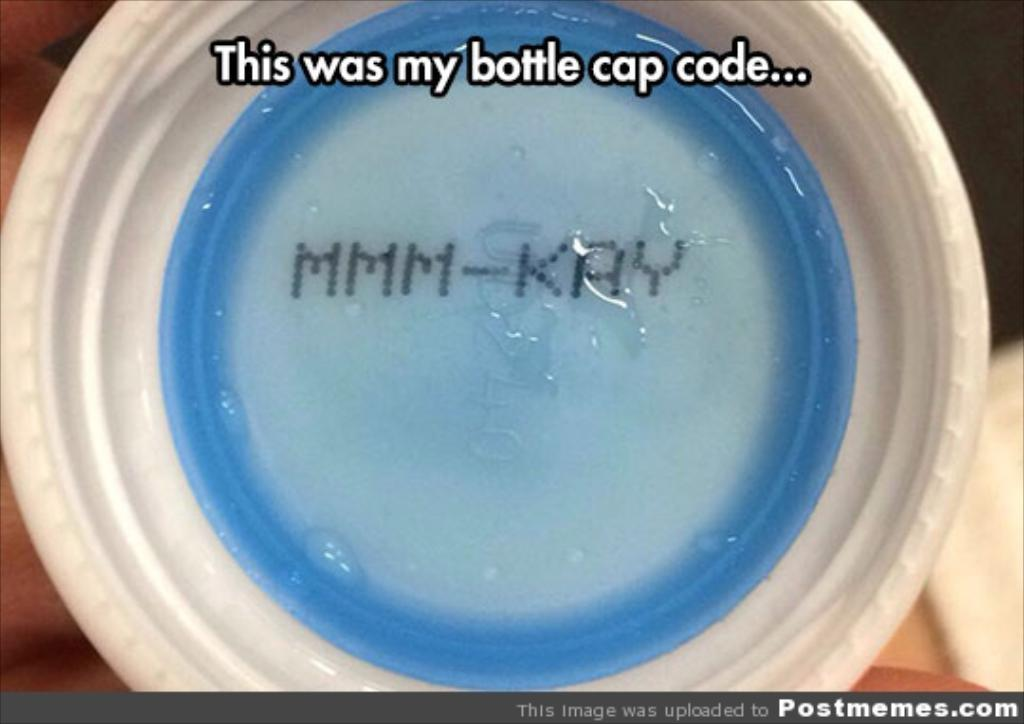What object is the main focus of the image? The main focus of the image is a bottle cap. Can you describe the appearance of the bottle cap? The bottle cap is white and blue in color. What text is written at the top of the image? The text "This was my bottle cap code..." is written at the top of the image. How would you describe the background of the image? The background of the image is blurred. Can you hear the sound of the crib in the image? There is no crib present in the image, and therefore no sound can be heard. 